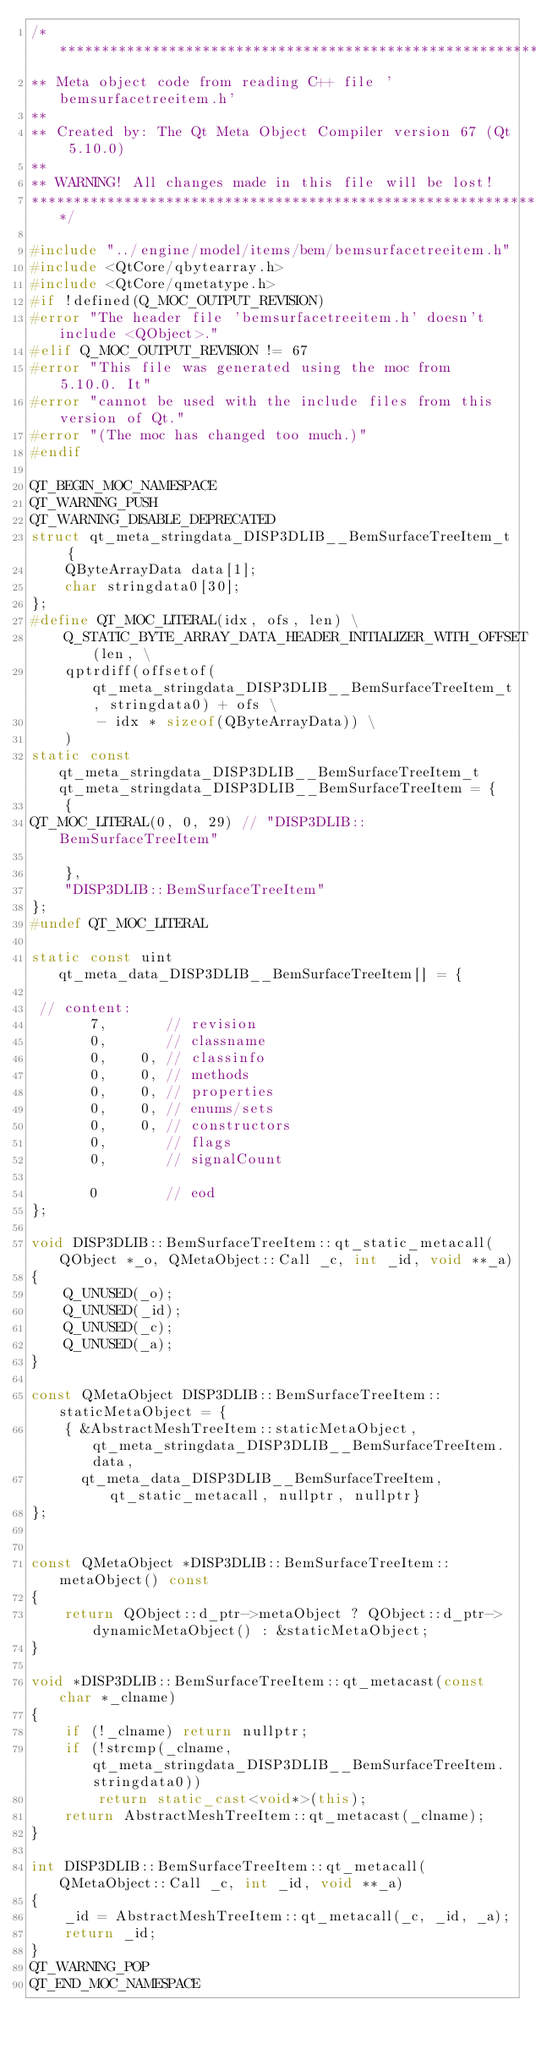<code> <loc_0><loc_0><loc_500><loc_500><_C++_>/****************************************************************************
** Meta object code from reading C++ file 'bemsurfacetreeitem.h'
**
** Created by: The Qt Meta Object Compiler version 67 (Qt 5.10.0)
**
** WARNING! All changes made in this file will be lost!
*****************************************************************************/

#include "../engine/model/items/bem/bemsurfacetreeitem.h"
#include <QtCore/qbytearray.h>
#include <QtCore/qmetatype.h>
#if !defined(Q_MOC_OUTPUT_REVISION)
#error "The header file 'bemsurfacetreeitem.h' doesn't include <QObject>."
#elif Q_MOC_OUTPUT_REVISION != 67
#error "This file was generated using the moc from 5.10.0. It"
#error "cannot be used with the include files from this version of Qt."
#error "(The moc has changed too much.)"
#endif

QT_BEGIN_MOC_NAMESPACE
QT_WARNING_PUSH
QT_WARNING_DISABLE_DEPRECATED
struct qt_meta_stringdata_DISP3DLIB__BemSurfaceTreeItem_t {
    QByteArrayData data[1];
    char stringdata0[30];
};
#define QT_MOC_LITERAL(idx, ofs, len) \
    Q_STATIC_BYTE_ARRAY_DATA_HEADER_INITIALIZER_WITH_OFFSET(len, \
    qptrdiff(offsetof(qt_meta_stringdata_DISP3DLIB__BemSurfaceTreeItem_t, stringdata0) + ofs \
        - idx * sizeof(QByteArrayData)) \
    )
static const qt_meta_stringdata_DISP3DLIB__BemSurfaceTreeItem_t qt_meta_stringdata_DISP3DLIB__BemSurfaceTreeItem = {
    {
QT_MOC_LITERAL(0, 0, 29) // "DISP3DLIB::BemSurfaceTreeItem"

    },
    "DISP3DLIB::BemSurfaceTreeItem"
};
#undef QT_MOC_LITERAL

static const uint qt_meta_data_DISP3DLIB__BemSurfaceTreeItem[] = {

 // content:
       7,       // revision
       0,       // classname
       0,    0, // classinfo
       0,    0, // methods
       0,    0, // properties
       0,    0, // enums/sets
       0,    0, // constructors
       0,       // flags
       0,       // signalCount

       0        // eod
};

void DISP3DLIB::BemSurfaceTreeItem::qt_static_metacall(QObject *_o, QMetaObject::Call _c, int _id, void **_a)
{
    Q_UNUSED(_o);
    Q_UNUSED(_id);
    Q_UNUSED(_c);
    Q_UNUSED(_a);
}

const QMetaObject DISP3DLIB::BemSurfaceTreeItem::staticMetaObject = {
    { &AbstractMeshTreeItem::staticMetaObject, qt_meta_stringdata_DISP3DLIB__BemSurfaceTreeItem.data,
      qt_meta_data_DISP3DLIB__BemSurfaceTreeItem,  qt_static_metacall, nullptr, nullptr}
};


const QMetaObject *DISP3DLIB::BemSurfaceTreeItem::metaObject() const
{
    return QObject::d_ptr->metaObject ? QObject::d_ptr->dynamicMetaObject() : &staticMetaObject;
}

void *DISP3DLIB::BemSurfaceTreeItem::qt_metacast(const char *_clname)
{
    if (!_clname) return nullptr;
    if (!strcmp(_clname, qt_meta_stringdata_DISP3DLIB__BemSurfaceTreeItem.stringdata0))
        return static_cast<void*>(this);
    return AbstractMeshTreeItem::qt_metacast(_clname);
}

int DISP3DLIB::BemSurfaceTreeItem::qt_metacall(QMetaObject::Call _c, int _id, void **_a)
{
    _id = AbstractMeshTreeItem::qt_metacall(_c, _id, _a);
    return _id;
}
QT_WARNING_POP
QT_END_MOC_NAMESPACE
</code> 